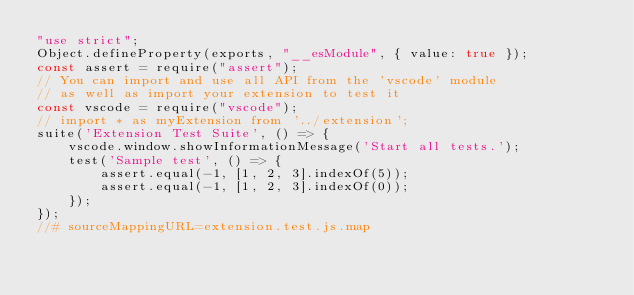<code> <loc_0><loc_0><loc_500><loc_500><_JavaScript_>"use strict";
Object.defineProperty(exports, "__esModule", { value: true });
const assert = require("assert");
// You can import and use all API from the 'vscode' module
// as well as import your extension to test it
const vscode = require("vscode");
// import * as myExtension from '../extension';
suite('Extension Test Suite', () => {
    vscode.window.showInformationMessage('Start all tests.');
    test('Sample test', () => {
        assert.equal(-1, [1, 2, 3].indexOf(5));
        assert.equal(-1, [1, 2, 3].indexOf(0));
    });
});
//# sourceMappingURL=extension.test.js.map</code> 